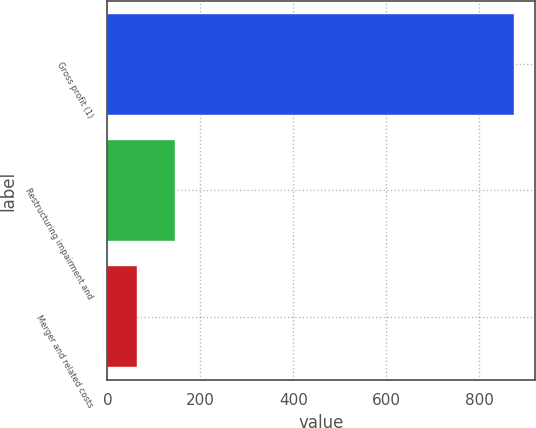<chart> <loc_0><loc_0><loc_500><loc_500><bar_chart><fcel>Gross profit (1)<fcel>Restructuring impairment and<fcel>Merger and related costs<nl><fcel>875<fcel>144.2<fcel>63<nl></chart> 